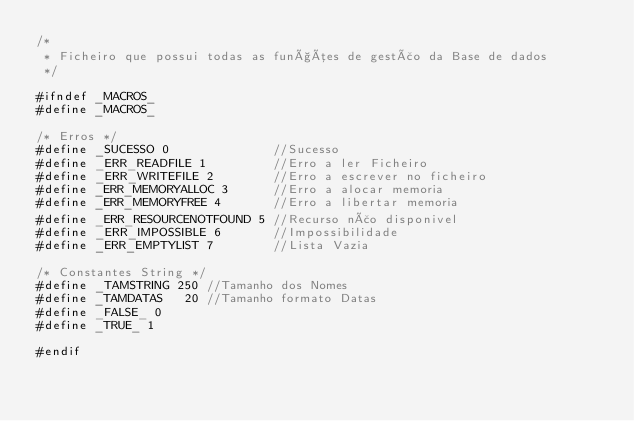<code> <loc_0><loc_0><loc_500><loc_500><_C_>/*
 * Ficheiro que possui todas as funções de gestão da Base de dados
 */

#ifndef _MACROS_
#define _MACROS_

/* Erros */
#define _SUCESSO 0              //Sucesso
#define _ERR_READFILE 1         //Erro a ler Ficheiro
#define _ERR_WRITEFILE 2        //Erro a escrever no ficheiro
#define _ERR_MEMORYALLOC 3      //Erro a alocar memoria
#define _ERR_MEMORYFREE 4       //Erro a libertar memoria
#define _ERR_RESOURCENOTFOUND 5 //Recurso não disponivel
#define _ERR_IMPOSSIBLE 6       //Impossibilidade
#define _ERR_EMPTYLIST 7        //Lista Vazia

/* Constantes String */
#define _TAMSTRING 250 //Tamanho dos Nomes
#define _TAMDATAS   20 //Tamanho formato Datas
#define _FALSE_ 0
#define _TRUE_ 1

#endif</code> 